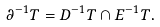Convert formula to latex. <formula><loc_0><loc_0><loc_500><loc_500>\partial ^ { - 1 } T = D ^ { - 1 } T \cap E ^ { - 1 } T .</formula> 